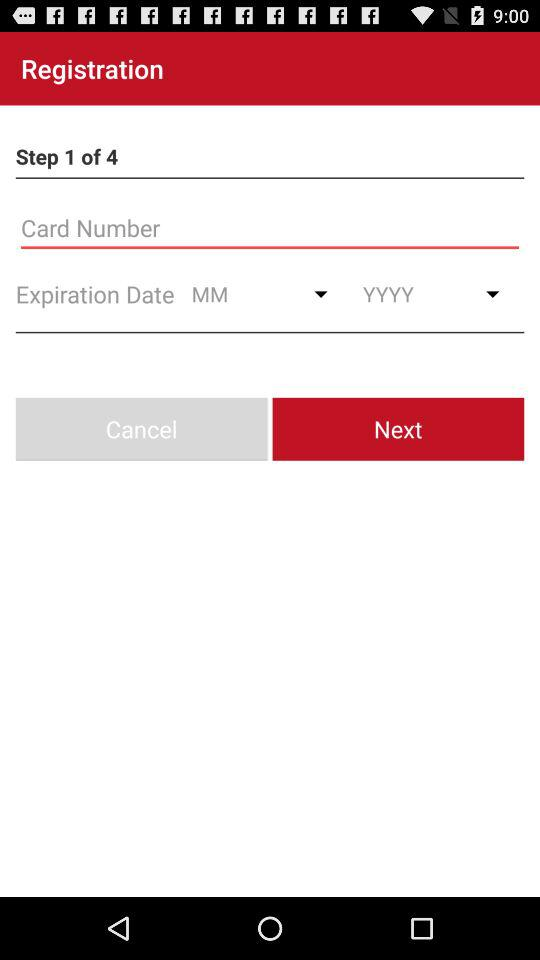Which step are we on? You are on step number 1. 